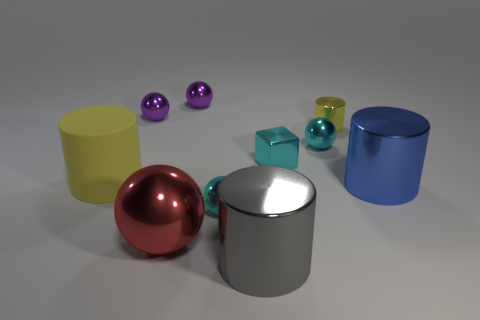Subtract all big red balls. How many balls are left? 4 Subtract 1 cylinders. How many cylinders are left? 3 Subtract all red balls. How many balls are left? 4 Subtract all gray spheres. Subtract all purple cubes. How many spheres are left? 5 Subtract all cylinders. How many objects are left? 6 Subtract 0 yellow blocks. How many objects are left? 10 Subtract all small yellow objects. Subtract all gray objects. How many objects are left? 8 Add 7 tiny cyan metal blocks. How many tiny cyan metal blocks are left? 8 Add 2 yellow shiny cylinders. How many yellow shiny cylinders exist? 3 